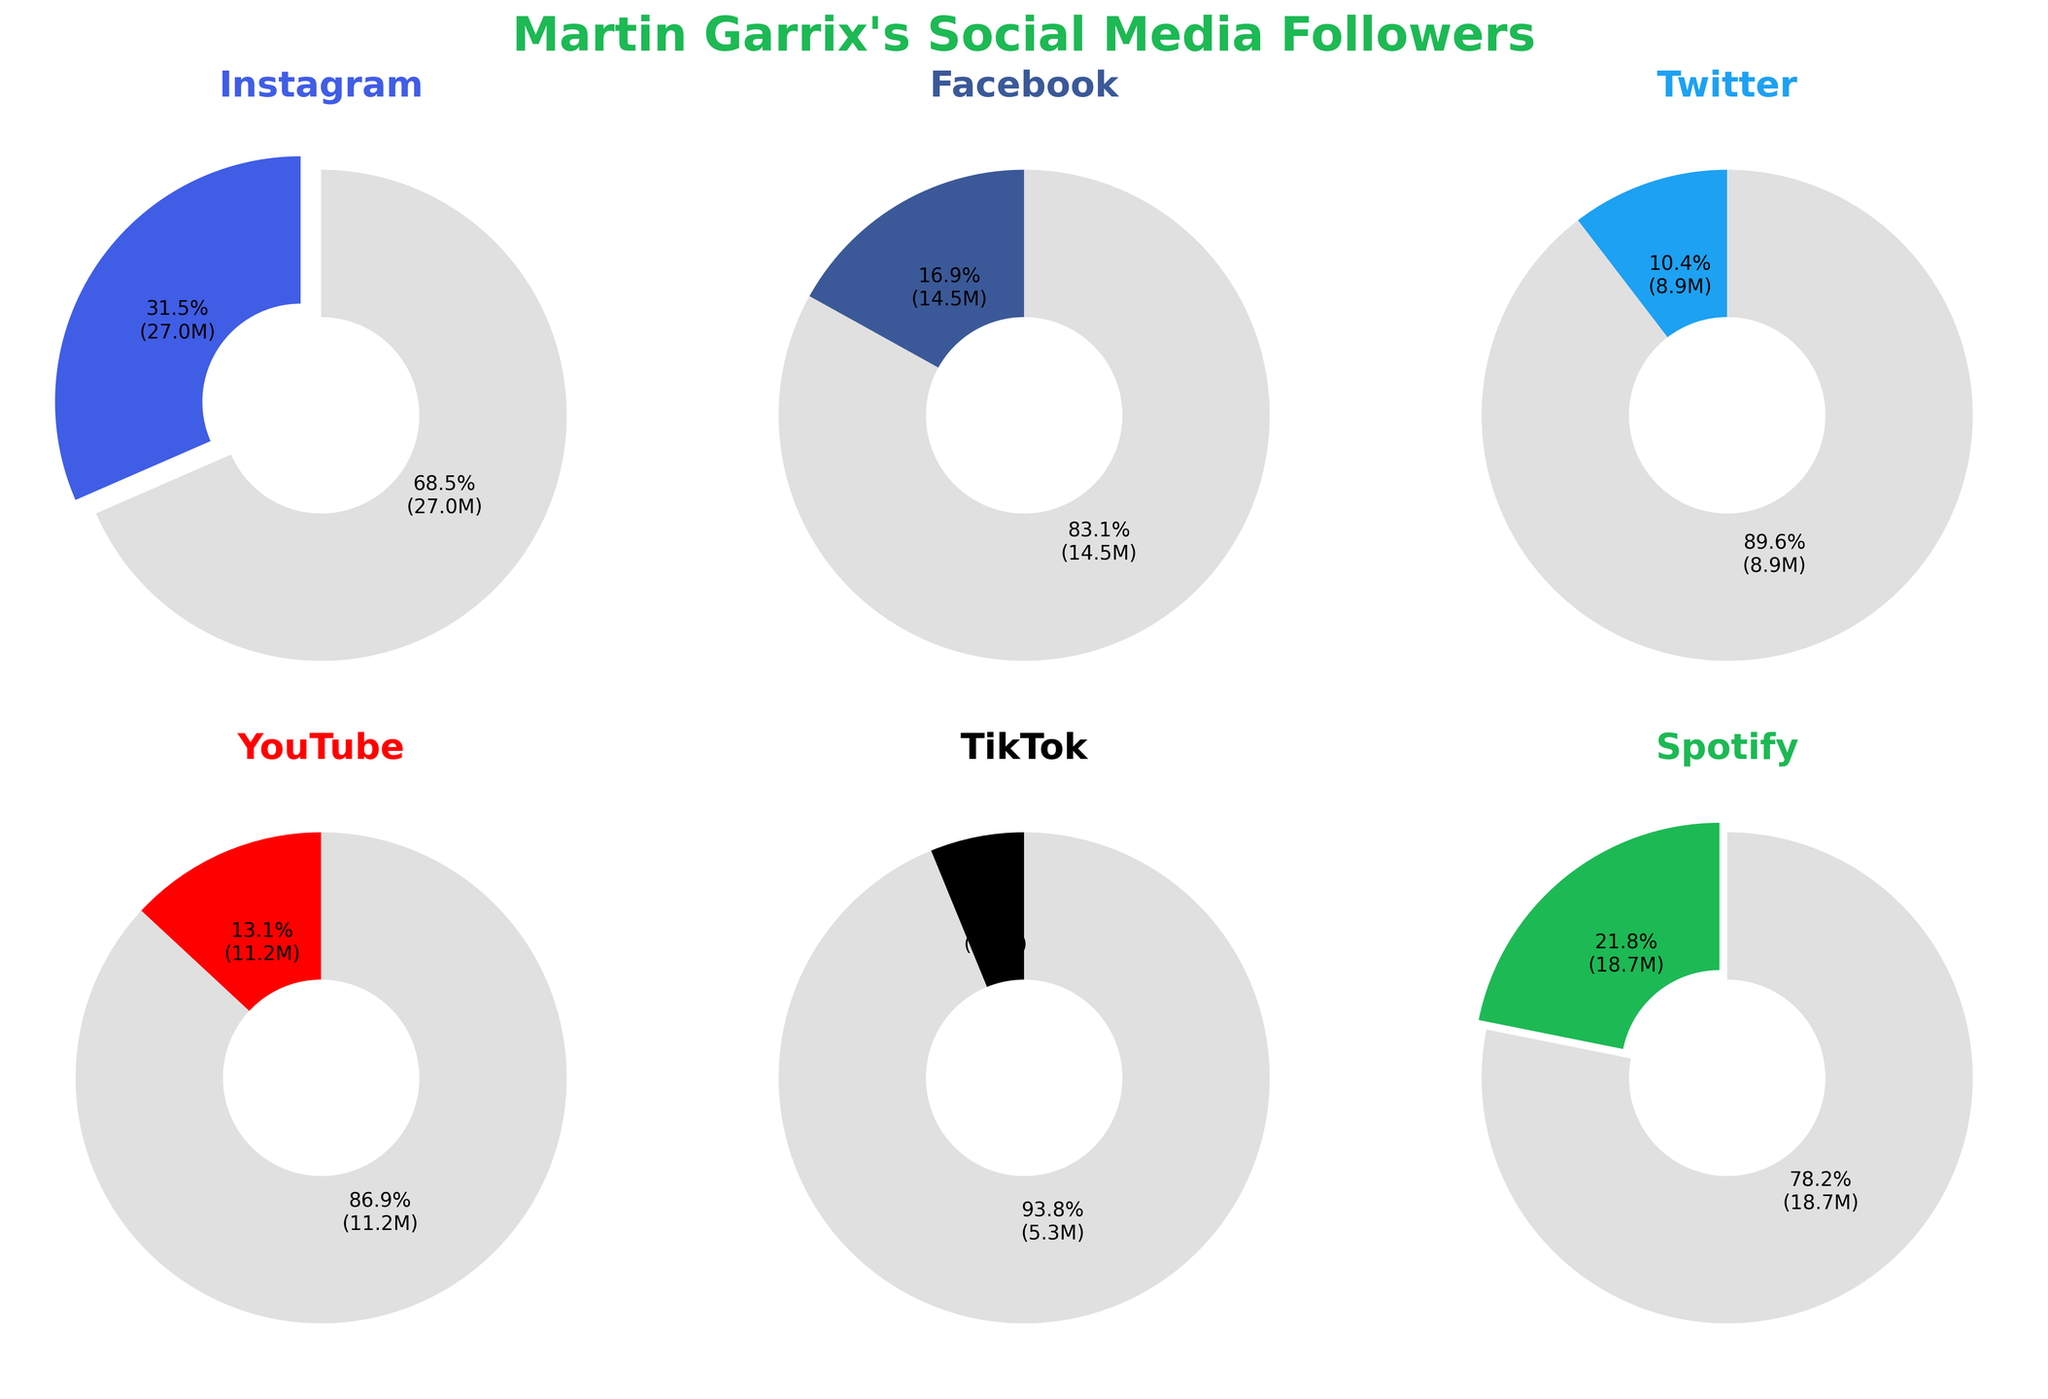What is the title of the figure? The title of a figure is typically located at the top. In this case, it reads "Martin Garrix's Social Media Followers".
Answer: Martin Garrix's Social Media Followers Which platform has the most followers? By looking at the pie charts, the Instagram pie chart has the largest colored slice, indicating it has the most followers.
Answer: Instagram What is the percentage of Martin Garrix's followers on Spotify? The Spotify pie chart shows approximately 21.5% for its colored slice.
Answer: 21.5% How many platforms have more than 10 million followers? By observing the follow counts in the pie charts and reading the autopct labels, we identify Instagram (27M), Facebook (14.5M), YouTube (11.2M), and Spotify (18.7M).
Answer: 4 Which platform has the fewest followers? TikTok has the smallest slice among all the platforms, indicating it has the fewest followers.
Answer: TikTok What is the percentage of followers on Twitter compared to the total followers? The Twitter pie chart shows a percentage a bit under 8%. This can be checked by calculating (8.9M / 87.6M) * 100 which is approximately 10.2%.
Answer: 10.2% How does the number of Instagram followers compare to the number of YouTube followers? Instagram has 27M followers, and YouTube has 11.2M followers. The difference is 27M - 11.2M = 15.8M.
Answer: 15.8M What is the percentage difference between the platform with the highest followers and the platform with the lowest followers? The highest count is for Instagram with 27M and the lowest is TikTok with 5.3M. The percentage difference can be calculated as ((27M - 5.3M)/27M) * 100 = 80.4%.
Answer: 80.4% How many total followers does Martin Garrix have across all platforms? Summing the followers from all platforms: 27M (Instagram) + 14.5M (Facebook) + 8.9M (Twitter) + 11.2M (YouTube) + 5.3M (TikTok) + 18.7M (Spotify) = 85.6M.
Answer: 85.6 million What percentage of followers does Martin Garrix have on Facebook and Instagram combined? Combining Instagram and Facebook gives 27M + 14.5M = 41.5M, which is 41.5M / 85.6M * 100 ≈ 48.5%.
Answer: 48.5% 